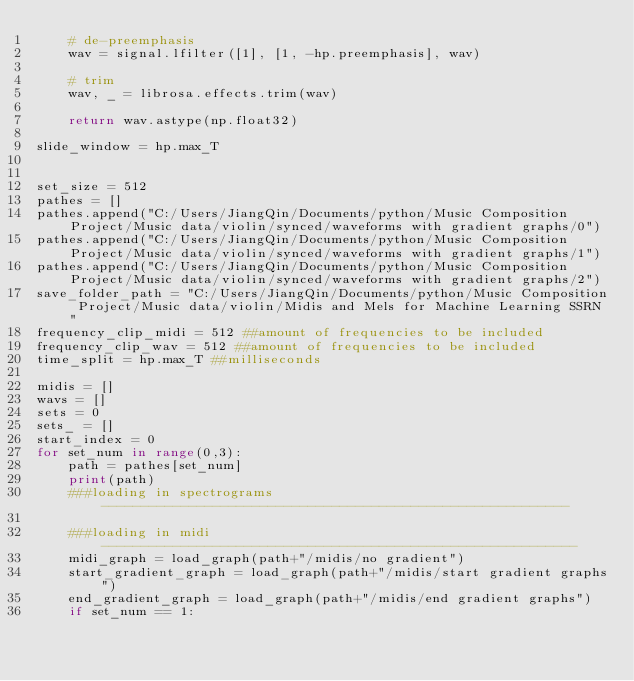<code> <loc_0><loc_0><loc_500><loc_500><_Python_>    # de-preemphasis
    wav = signal.lfilter([1], [1, -hp.preemphasis], wav)

    # trim
    wav, _ = librosa.effects.trim(wav)

    return wav.astype(np.float32)

slide_window = hp.max_T


set_size = 512
pathes = []
pathes.append("C:/Users/JiangQin/Documents/python/Music Composition Project/Music data/violin/synced/waveforms with gradient graphs/0")
pathes.append("C:/Users/JiangQin/Documents/python/Music Composition Project/Music data/violin/synced/waveforms with gradient graphs/1")
pathes.append("C:/Users/JiangQin/Documents/python/Music Composition Project/Music data/violin/synced/waveforms with gradient graphs/2")
save_folder_path = "C:/Users/JiangQin/Documents/python/Music Composition Project/Music data/violin/Midis and Mels for Machine Learning SSRN"
frequency_clip_midi = 512 ##amount of frequencies to be included
frequency_clip_wav = 512 ##amount of frequencies to be included
time_split = hp.max_T ##milliseconds

midis = []
wavs = []
sets = 0
sets_ = []
start_index = 0
for set_num in range(0,3):
    path = pathes[set_num]
    print(path)
    ###loading in spectrograms-----------------------------------------------------------
    
    ###loading in midi------------------------------------------------------------
    midi_graph = load_graph(path+"/midis/no gradient")
    start_gradient_graph = load_graph(path+"/midis/start gradient graphs")       
    end_gradient_graph = load_graph(path+"/midis/end gradient graphs")
    if set_num == 1:</code> 